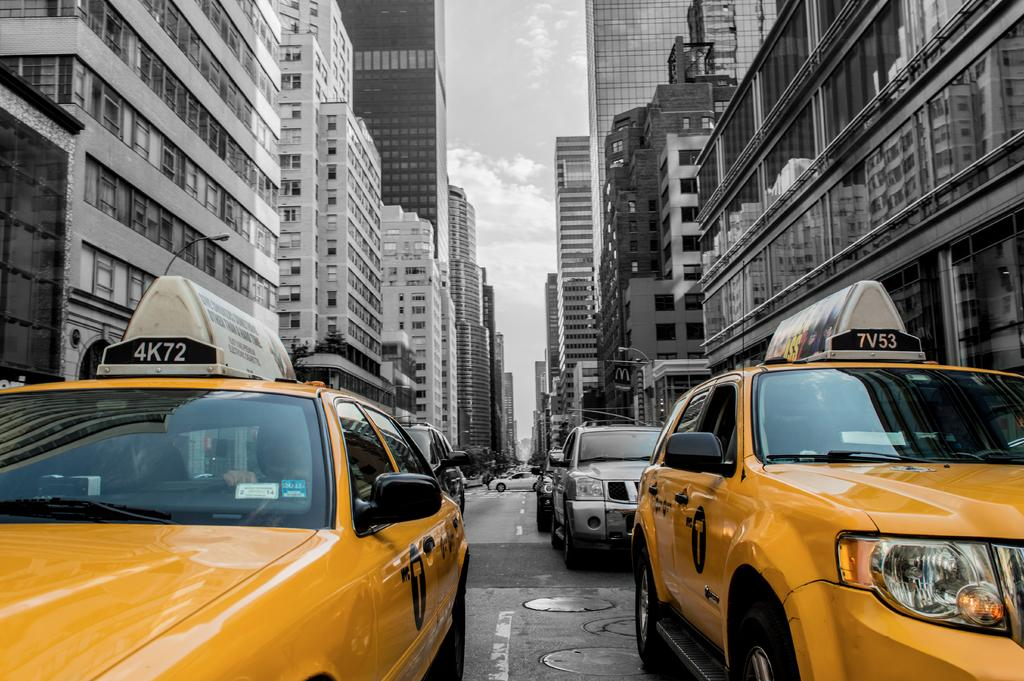<image>
Create a compact narrative representing the image presented. a taxi cab that has 7V53 at the top of it 